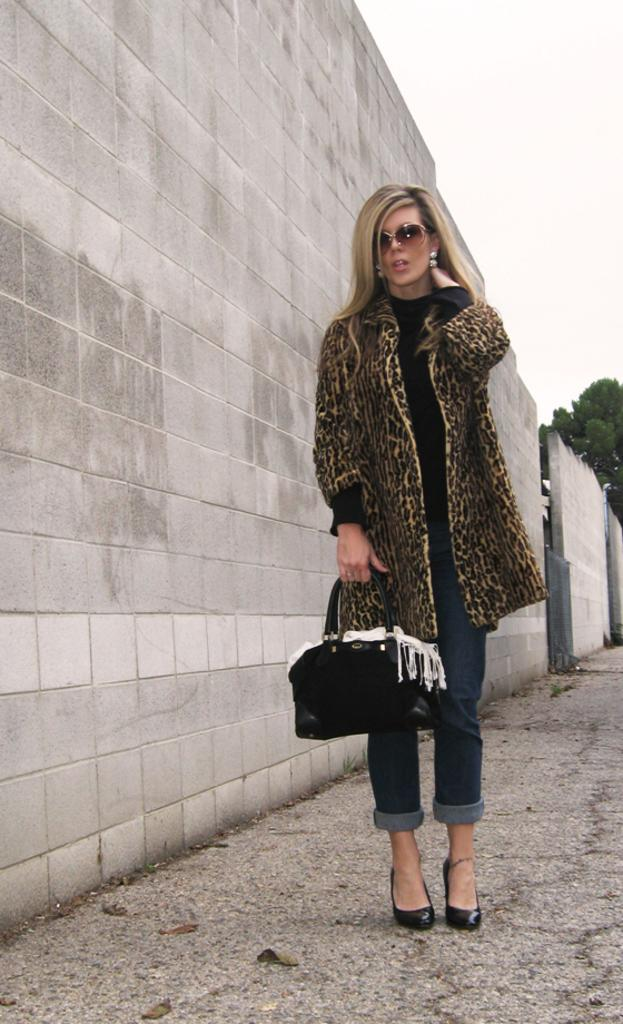What is the main subject of the image? There is a woman standing in the middle of the image. What is the woman holding in the image? The woman is holding a bag. What is located beside the woman in the image? There is a wall beside the woman. What can be seen in the top right side of the image? The top right side of the image contains the sky and a tree. How much tax does the woman have to pay for the iron she is holding in the image? There is no iron present in the image, and the woman is not holding anything other than a bag. 